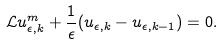<formula> <loc_0><loc_0><loc_500><loc_500>\mathcal { L } u _ { \epsilon , k } ^ { m } + \frac { 1 } { \epsilon } ( u _ { \epsilon , k } - u _ { \epsilon , k - 1 } ) = 0 .</formula> 